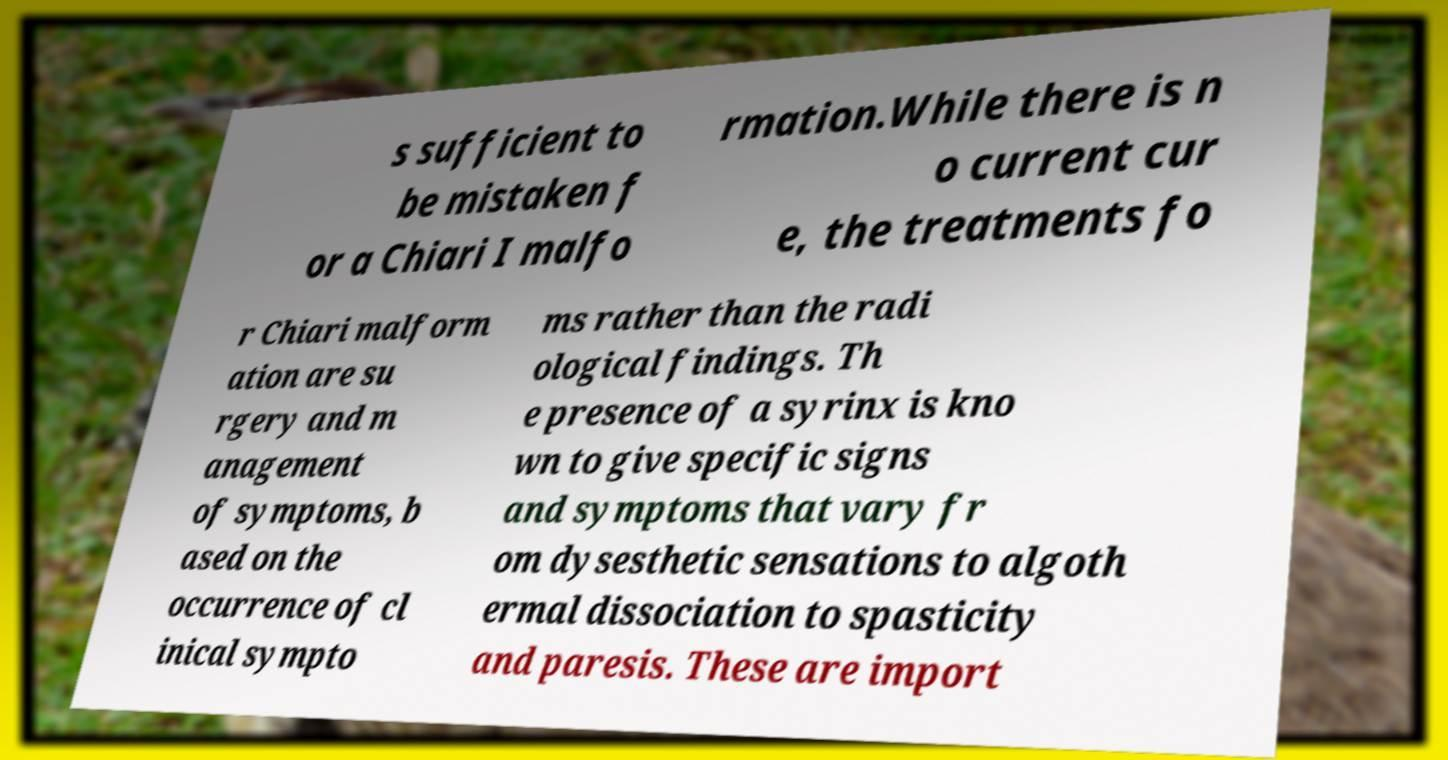What messages or text are displayed in this image? I need them in a readable, typed format. s sufficient to be mistaken f or a Chiari I malfo rmation.While there is n o current cur e, the treatments fo r Chiari malform ation are su rgery and m anagement of symptoms, b ased on the occurrence of cl inical sympto ms rather than the radi ological findings. Th e presence of a syrinx is kno wn to give specific signs and symptoms that vary fr om dysesthetic sensations to algoth ermal dissociation to spasticity and paresis. These are import 